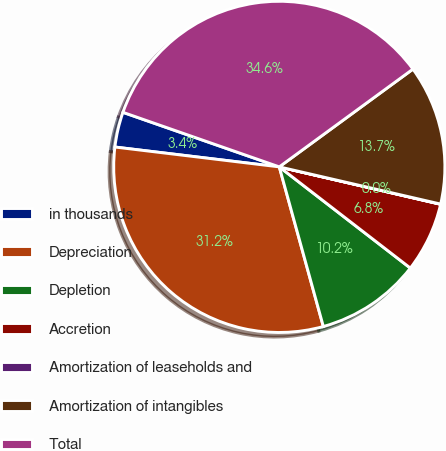<chart> <loc_0><loc_0><loc_500><loc_500><pie_chart><fcel>in thousands<fcel>Depreciation<fcel>Depletion<fcel>Accretion<fcel>Amortization of leaseholds and<fcel>Amortization of intangibles<fcel>Total<nl><fcel>3.43%<fcel>31.2%<fcel>10.25%<fcel>6.84%<fcel>0.02%<fcel>13.66%<fcel>34.61%<nl></chart> 